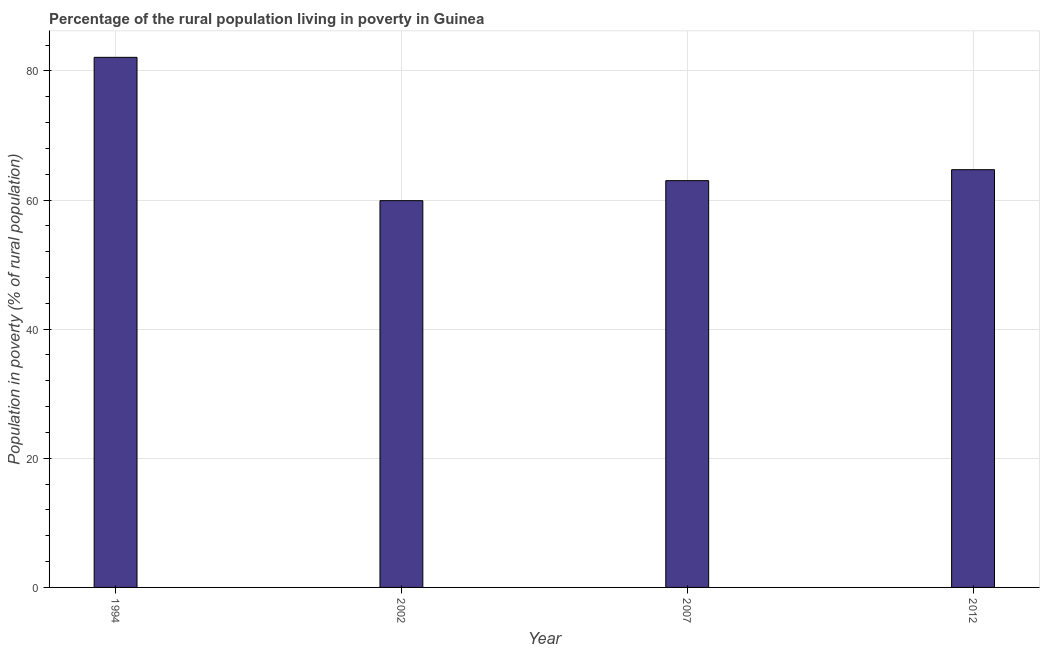Does the graph contain grids?
Your answer should be compact. Yes. What is the title of the graph?
Keep it short and to the point. Percentage of the rural population living in poverty in Guinea. What is the label or title of the X-axis?
Provide a succinct answer. Year. What is the label or title of the Y-axis?
Offer a terse response. Population in poverty (% of rural population). What is the percentage of rural population living below poverty line in 1994?
Offer a terse response. 82.1. Across all years, what is the maximum percentage of rural population living below poverty line?
Your response must be concise. 82.1. Across all years, what is the minimum percentage of rural population living below poverty line?
Offer a terse response. 59.9. In which year was the percentage of rural population living below poverty line minimum?
Provide a succinct answer. 2002. What is the sum of the percentage of rural population living below poverty line?
Offer a very short reply. 269.7. What is the average percentage of rural population living below poverty line per year?
Provide a succinct answer. 67.42. What is the median percentage of rural population living below poverty line?
Provide a short and direct response. 63.85. Do a majority of the years between 2002 and 2007 (inclusive) have percentage of rural population living below poverty line greater than 28 %?
Keep it short and to the point. Yes. What is the ratio of the percentage of rural population living below poverty line in 2002 to that in 2007?
Offer a very short reply. 0.95. Is the percentage of rural population living below poverty line in 2002 less than that in 2007?
Make the answer very short. Yes. Is the difference between the percentage of rural population living below poverty line in 2002 and 2007 greater than the difference between any two years?
Provide a short and direct response. No. Is the sum of the percentage of rural population living below poverty line in 1994 and 2012 greater than the maximum percentage of rural population living below poverty line across all years?
Provide a succinct answer. Yes. What is the difference between the highest and the lowest percentage of rural population living below poverty line?
Provide a short and direct response. 22.2. In how many years, is the percentage of rural population living below poverty line greater than the average percentage of rural population living below poverty line taken over all years?
Provide a succinct answer. 1. How many bars are there?
Provide a short and direct response. 4. How many years are there in the graph?
Give a very brief answer. 4. What is the Population in poverty (% of rural population) of 1994?
Your answer should be very brief. 82.1. What is the Population in poverty (% of rural population) in 2002?
Your response must be concise. 59.9. What is the Population in poverty (% of rural population) of 2007?
Keep it short and to the point. 63. What is the Population in poverty (% of rural population) of 2012?
Provide a short and direct response. 64.7. What is the difference between the Population in poverty (% of rural population) in 1994 and 2002?
Make the answer very short. 22.2. What is the difference between the Population in poverty (% of rural population) in 2007 and 2012?
Keep it short and to the point. -1.7. What is the ratio of the Population in poverty (% of rural population) in 1994 to that in 2002?
Offer a terse response. 1.37. What is the ratio of the Population in poverty (% of rural population) in 1994 to that in 2007?
Keep it short and to the point. 1.3. What is the ratio of the Population in poverty (% of rural population) in 1994 to that in 2012?
Give a very brief answer. 1.27. What is the ratio of the Population in poverty (% of rural population) in 2002 to that in 2007?
Offer a very short reply. 0.95. What is the ratio of the Population in poverty (% of rural population) in 2002 to that in 2012?
Provide a succinct answer. 0.93. 